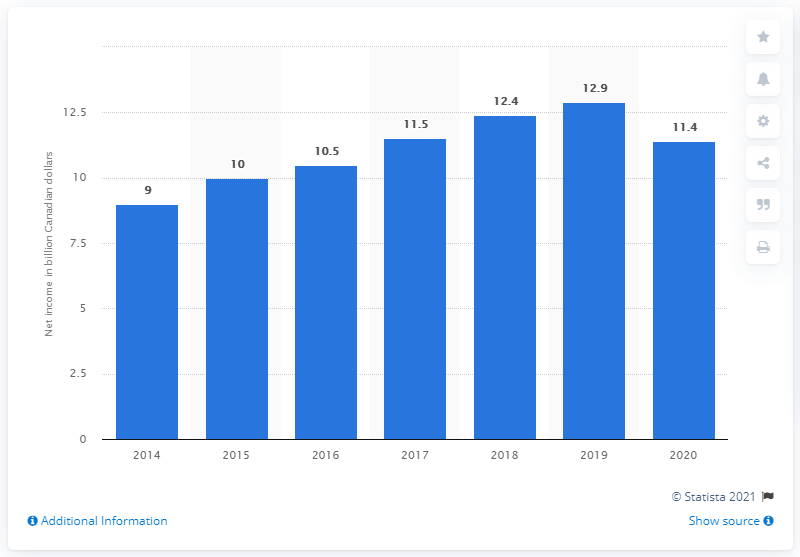Identify some key points in this picture. In 2020, the leading Canadian bank reported a net income of CAD 11.4 billion. 